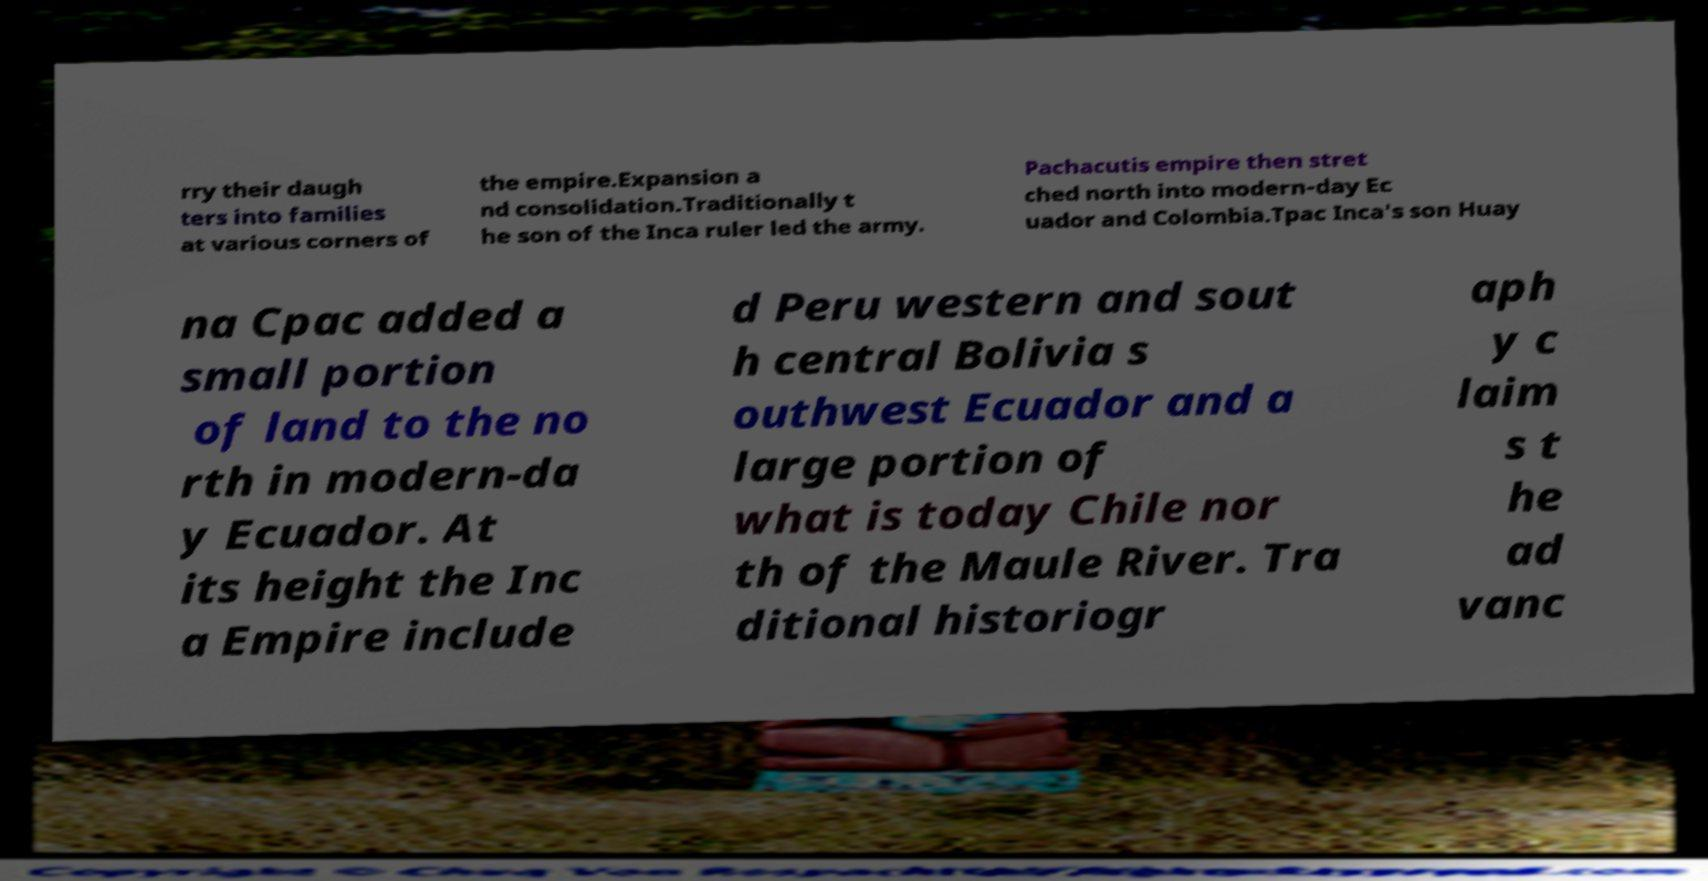I need the written content from this picture converted into text. Can you do that? rry their daugh ters into families at various corners of the empire.Expansion a nd consolidation.Traditionally t he son of the Inca ruler led the army. Pachacutis empire then stret ched north into modern-day Ec uador and Colombia.Tpac Inca's son Huay na Cpac added a small portion of land to the no rth in modern-da y Ecuador. At its height the Inc a Empire include d Peru western and sout h central Bolivia s outhwest Ecuador and a large portion of what is today Chile nor th of the Maule River. Tra ditional historiogr aph y c laim s t he ad vanc 